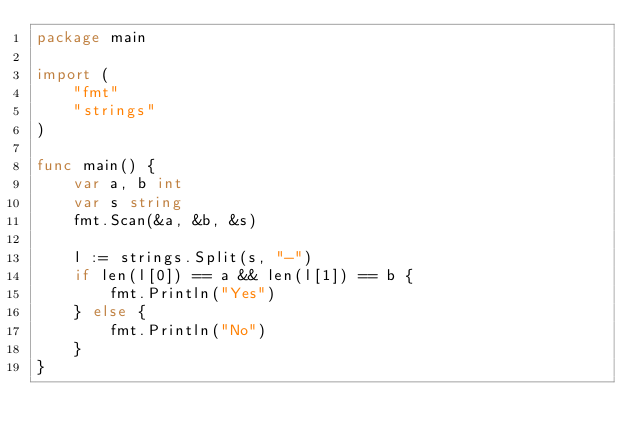Convert code to text. <code><loc_0><loc_0><loc_500><loc_500><_Go_>package main

import (
	"fmt"
	"strings"
)

func main() {
	var a, b int
	var s string
	fmt.Scan(&a, &b, &s)

	l := strings.Split(s, "-")
	if len(l[0]) == a && len(l[1]) == b {
		fmt.Println("Yes")
	} else {
		fmt.Println("No")
	}
}
</code> 